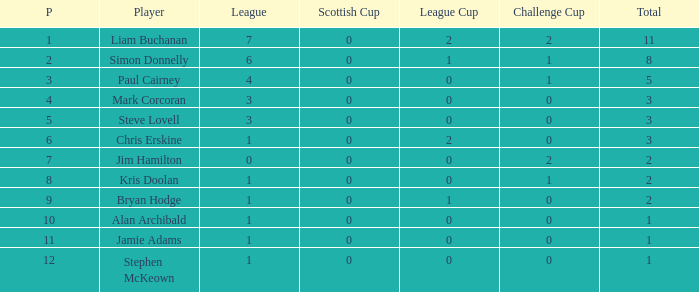What was the least number of points scored in the league cup? 0.0. 